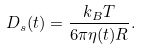<formula> <loc_0><loc_0><loc_500><loc_500>D _ { s } ( t ) = \frac { k _ { B } T } { 6 \pi \eta ( t ) R } .</formula> 